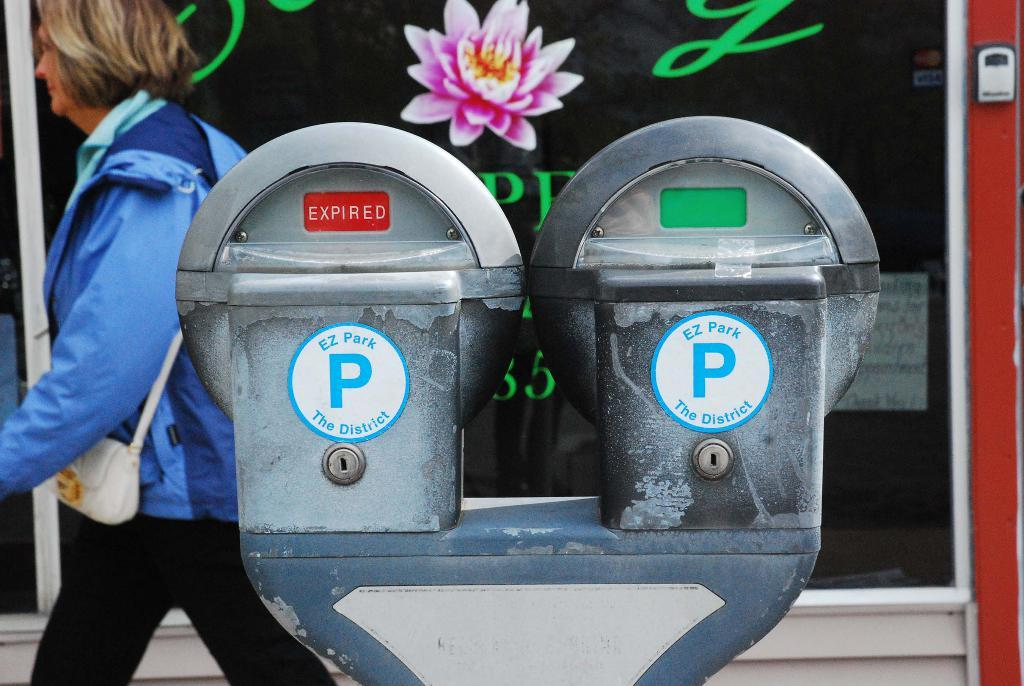Provide a one-sentence caption for the provided image. woman walking past 2 ez park parking meters, one expired, one not. 